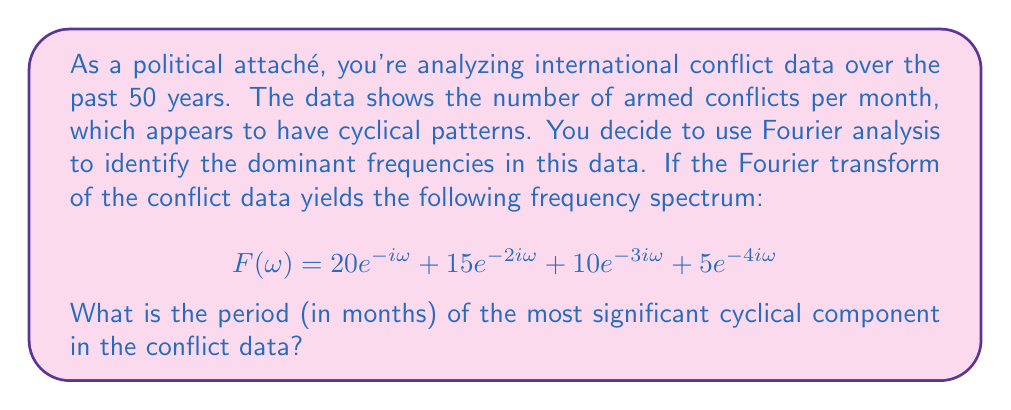Can you solve this math problem? To solve this problem, we need to follow these steps:

1) In the given Fourier transform, each term represents a frequency component:
   $$20e^{-i\omega}, 15e^{-2i\omega}, 10e^{-3i\omega}, 5e^{-4i\omega}$$

2) The magnitude of each term represents the significance of that frequency. The largest magnitude is 20, corresponding to $e^{-i\omega}$.

3) The frequency $\omega$ is related to the period $T$ by the equation:
   $$\omega = \frac{2\pi}{T}$$

4) In our case, the most significant component has $\omega = 1$ (because it's $e^{-i\omega}$, not $e^{-2i\omega}$ or $e^{-3i\omega}$, etc.)

5) Substituting this into the equation from step 3:
   $$1 = \frac{2\pi}{T}$$

6) Solving for $T$:
   $$T = 2\pi$$

7) Since we're working with monthly data, this period is in months. We should round to the nearest whole number.

Thus, the period of the most significant cyclical component is approximately 6 months (as $2\pi \approx 6.28$).
Answer: 6 months 